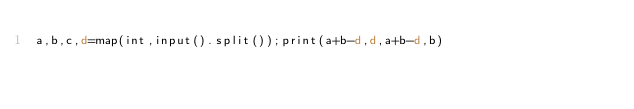Convert code to text. <code><loc_0><loc_0><loc_500><loc_500><_dc_>a,b,c,d=map(int,input().split());print(a+b-d,d,a+b-d,b)</code> 